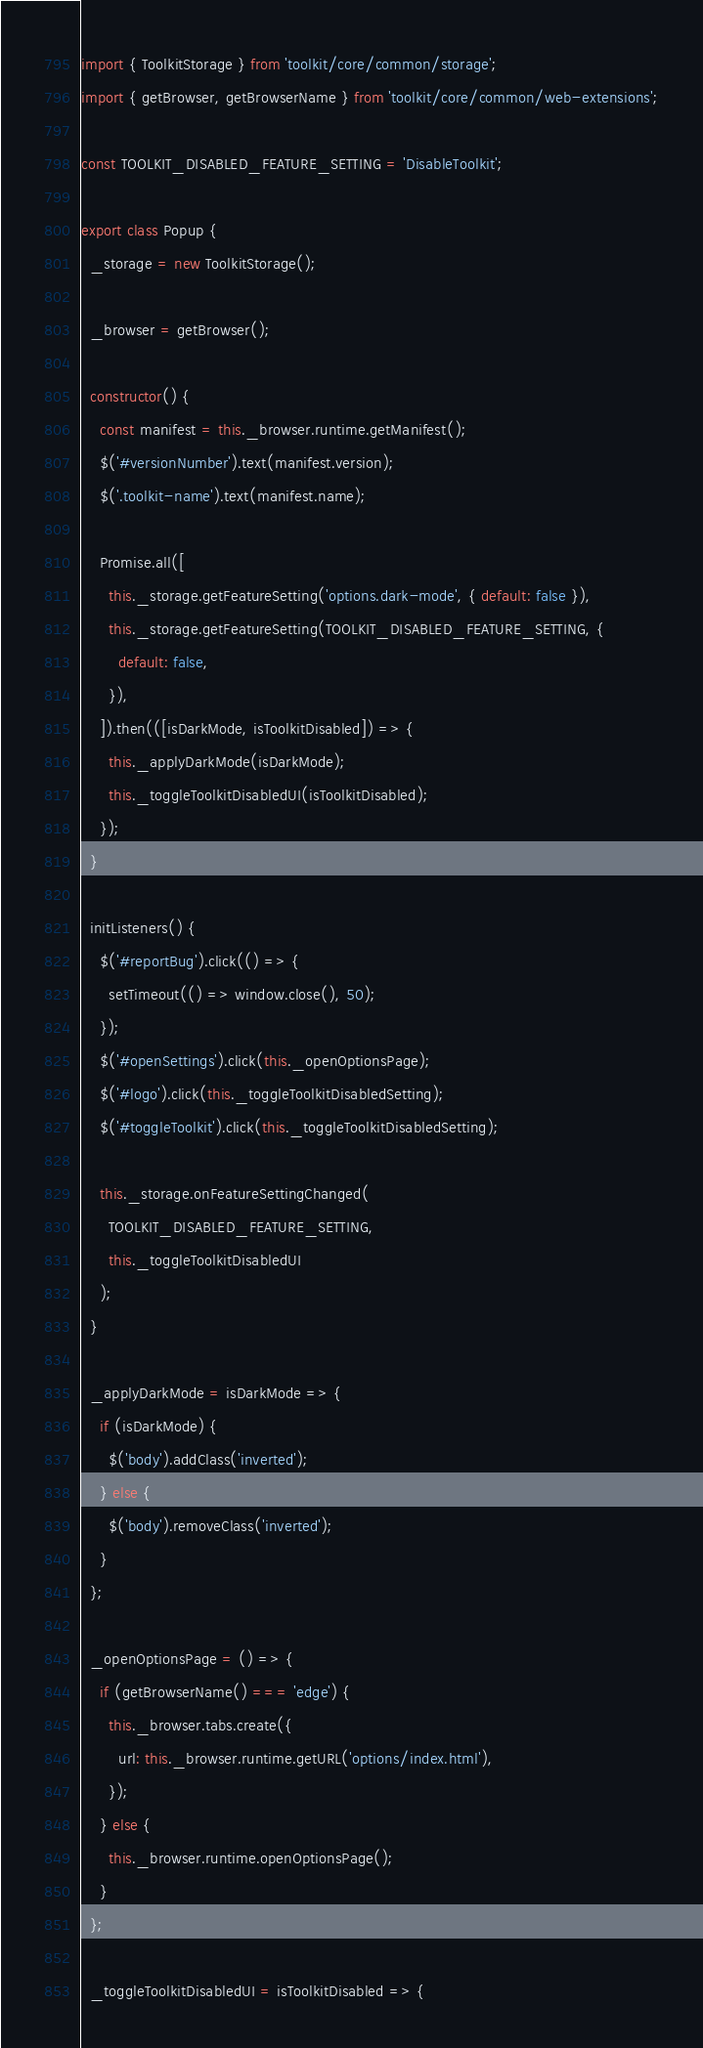<code> <loc_0><loc_0><loc_500><loc_500><_JavaScript_>import { ToolkitStorage } from 'toolkit/core/common/storage';
import { getBrowser, getBrowserName } from 'toolkit/core/common/web-extensions';

const TOOLKIT_DISABLED_FEATURE_SETTING = 'DisableToolkit';

export class Popup {
  _storage = new ToolkitStorage();

  _browser = getBrowser();

  constructor() {
    const manifest = this._browser.runtime.getManifest();
    $('#versionNumber').text(manifest.version);
    $('.toolkit-name').text(manifest.name);

    Promise.all([
      this._storage.getFeatureSetting('options.dark-mode', { default: false }),
      this._storage.getFeatureSetting(TOOLKIT_DISABLED_FEATURE_SETTING, {
        default: false,
      }),
    ]).then(([isDarkMode, isToolkitDisabled]) => {
      this._applyDarkMode(isDarkMode);
      this._toggleToolkitDisabledUI(isToolkitDisabled);
    });
  }

  initListeners() {
    $('#reportBug').click(() => {
      setTimeout(() => window.close(), 50);
    });
    $('#openSettings').click(this._openOptionsPage);
    $('#logo').click(this._toggleToolkitDisabledSetting);
    $('#toggleToolkit').click(this._toggleToolkitDisabledSetting);

    this._storage.onFeatureSettingChanged(
      TOOLKIT_DISABLED_FEATURE_SETTING,
      this._toggleToolkitDisabledUI
    );
  }

  _applyDarkMode = isDarkMode => {
    if (isDarkMode) {
      $('body').addClass('inverted');
    } else {
      $('body').removeClass('inverted');
    }
  };

  _openOptionsPage = () => {
    if (getBrowserName() === 'edge') {
      this._browser.tabs.create({
        url: this._browser.runtime.getURL('options/index.html'),
      });
    } else {
      this._browser.runtime.openOptionsPage();
    }
  };

  _toggleToolkitDisabledUI = isToolkitDisabled => {</code> 